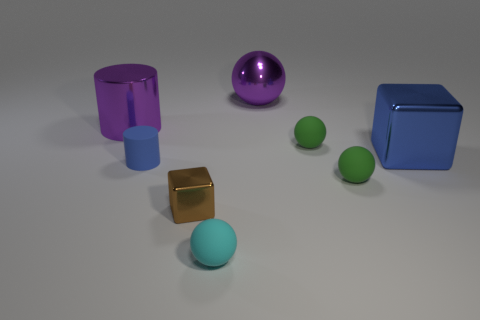Do the brown metal block and the purple metallic cylinder have the same size?
Offer a very short reply. No. Is there a tiny green rubber thing that is behind the green rubber ball that is behind the big blue metallic cube right of the tiny cyan matte thing?
Your answer should be compact. No. What is the material of the purple thing that is the same shape as the cyan object?
Keep it short and to the point. Metal. There is a tiny brown object that is in front of the metal cylinder; what number of purple metal spheres are left of it?
Offer a terse response. 0. What size is the purple metal object on the right side of the brown shiny thing that is in front of the rubber cylinder behind the cyan object?
Keep it short and to the point. Large. There is a sphere that is right of the tiny green object that is behind the big metallic block; what is its color?
Your answer should be compact. Green. How many other objects are there of the same material as the tiny brown cube?
Keep it short and to the point. 3. What number of other objects are the same color as the large cube?
Ensure brevity in your answer.  1. The big thing left of the cube that is in front of the small matte cylinder is made of what material?
Your answer should be very brief. Metal. Are any cylinders visible?
Ensure brevity in your answer.  Yes. 